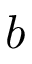Convert formula to latex. <formula><loc_0><loc_0><loc_500><loc_500>b</formula> 